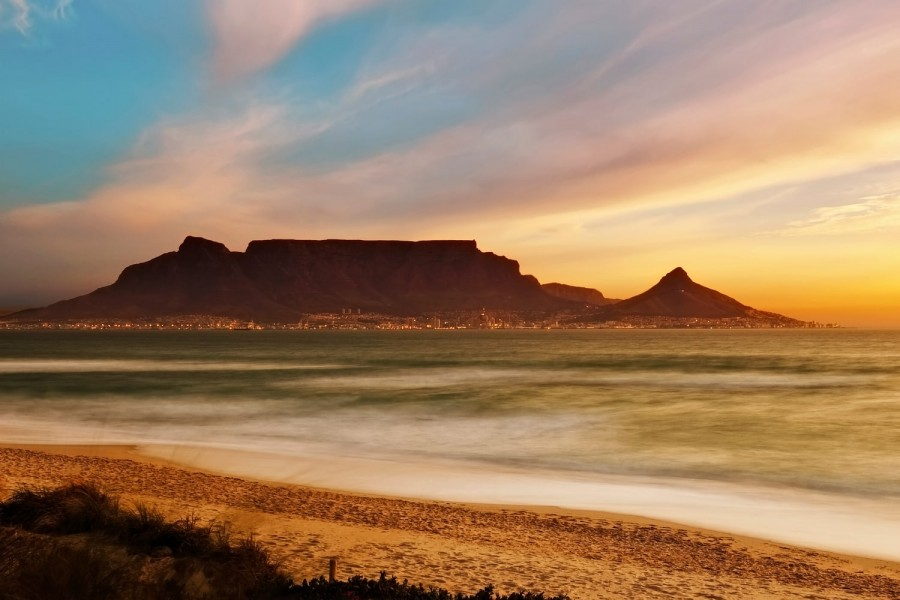Describe the natural and urban elements split in this image. The image elegantly divides natural and urban elements, creating a harmonious balance between nature and civilization. On the natural side, the prominent Table Mountain dominates the skyline with its flat-top silhouette, accompanied by the sprawling ocean in the foreground, which displays a tranquil light blue-green hue and blurred waves indicative of long exposure photography. The sky above, painted in dramatic hues of orange and blue, is dotted with wispy clouds adding further texture and depth. On the urban side, at the base of the mountain, city lights glisten, hinting at a bustling metropolis contrasting the serene natural environment. These lights add a dynamic and lively element to the tranquil landscape, symbolizing the coexistence of urban life and natural beauty. 